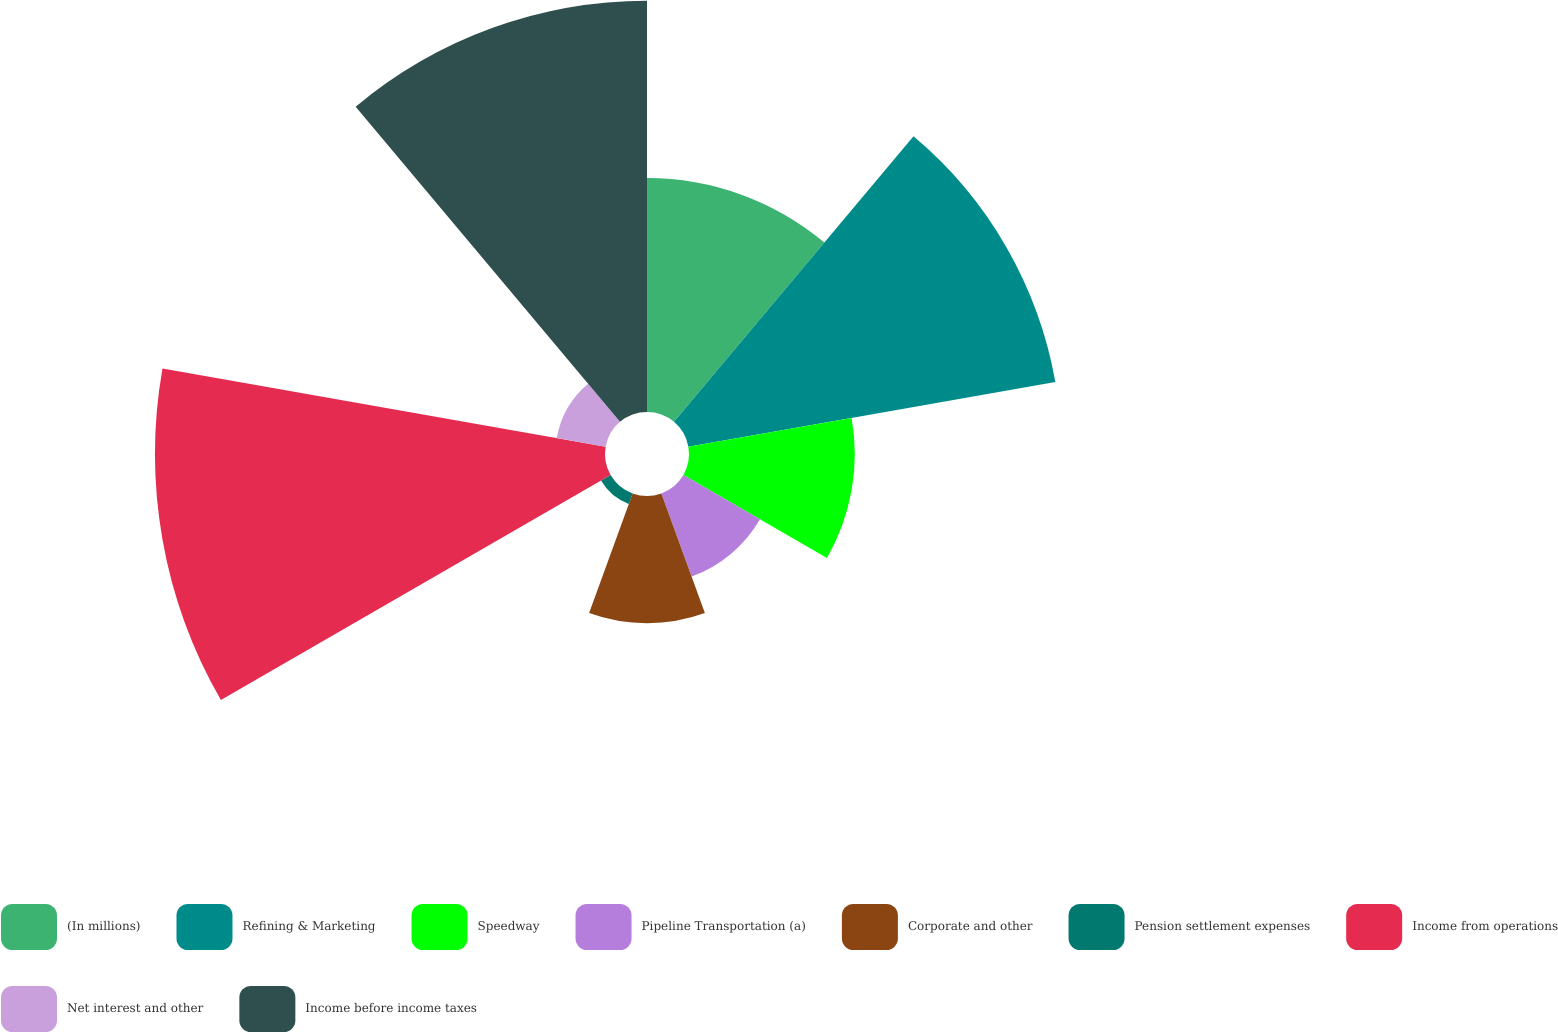<chart> <loc_0><loc_0><loc_500><loc_500><pie_chart><fcel>(In millions)<fcel>Refining & Marketing<fcel>Speedway<fcel>Pipeline Transportation (a)<fcel>Corporate and other<fcel>Pension settlement expenses<fcel>Income from operations<fcel>Net interest and other<fcel>Income before income taxes<nl><fcel>12.25%<fcel>19.51%<fcel>8.68%<fcel>4.63%<fcel>6.66%<fcel>0.58%<fcel>23.56%<fcel>2.6%<fcel>21.53%<nl></chart> 